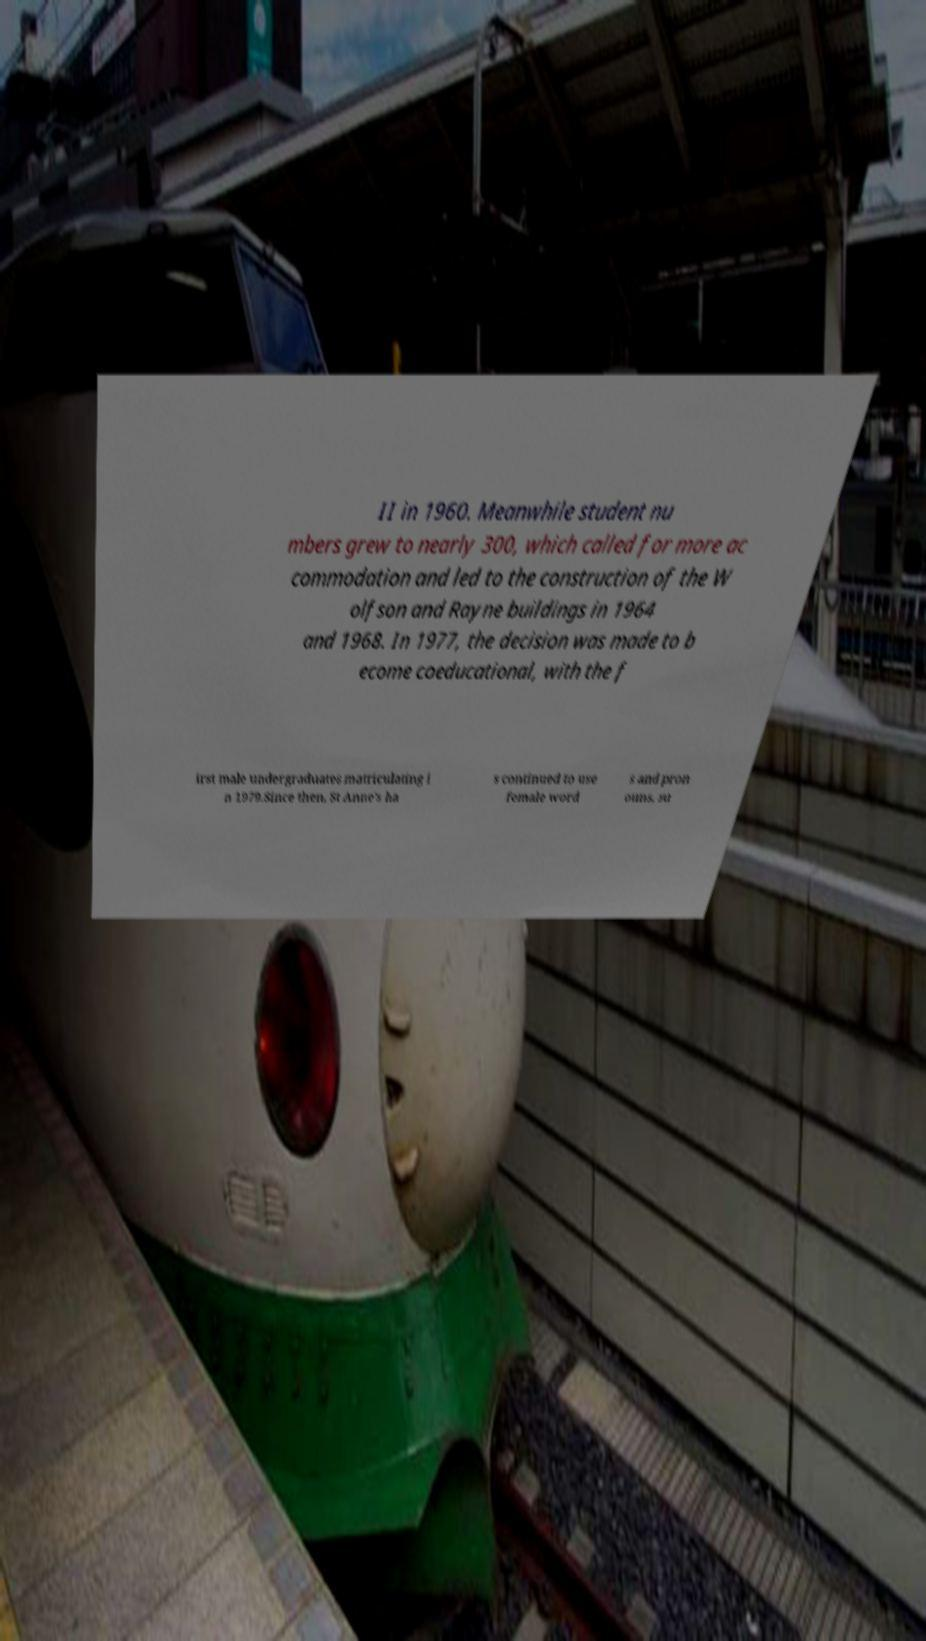Can you accurately transcribe the text from the provided image for me? II in 1960. Meanwhile student nu mbers grew to nearly 300, which called for more ac commodation and led to the construction of the W olfson and Rayne buildings in 1964 and 1968. In 1977, the decision was made to b ecome coeducational, with the f irst male undergraduates matriculating i n 1979.Since then, St Anne's ha s continued to use female word s and pron ouns, su 